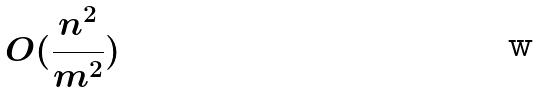Convert formula to latex. <formula><loc_0><loc_0><loc_500><loc_500>O ( \frac { n ^ { 2 } } { m ^ { 2 } } )</formula> 